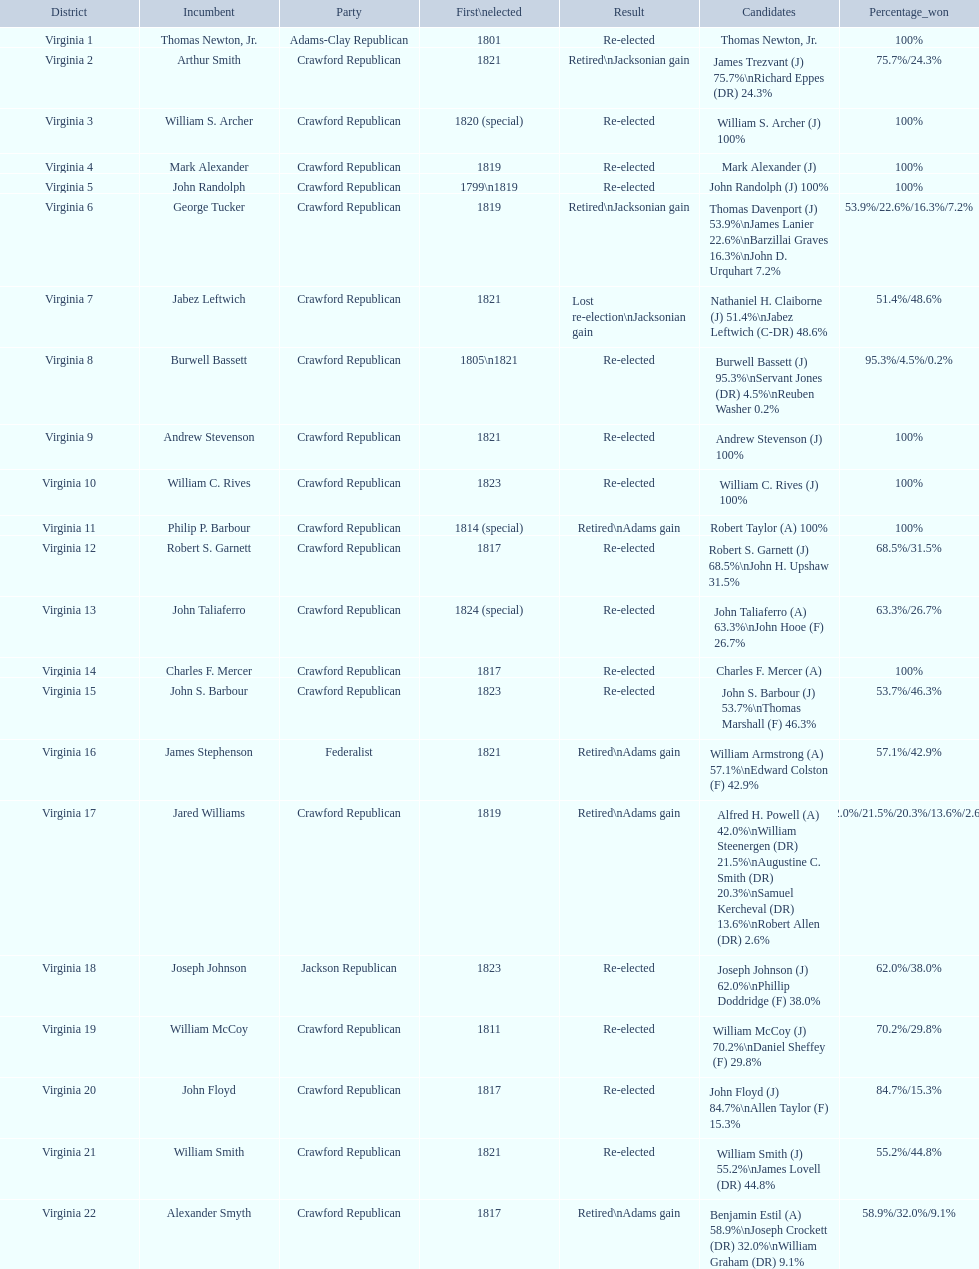How many districts are there in virginia? 22. 